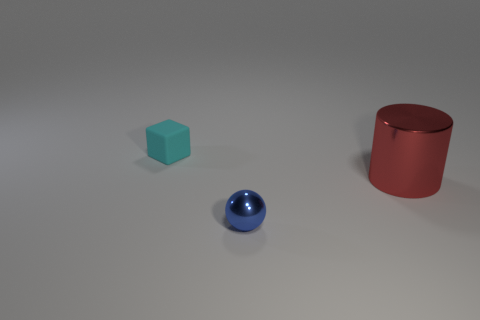Is there anything else that has the same size as the red cylinder?
Offer a terse response. No. Are there any other things that have the same shape as the cyan rubber thing?
Your answer should be very brief. No. There is a tiny matte thing on the left side of the red metallic thing; what is its shape?
Offer a very short reply. Cube. There is a object to the left of the blue object; is its size the same as the blue object?
Ensure brevity in your answer.  Yes. What is the size of the object that is behind the shiny ball and in front of the tiny cyan thing?
Your response must be concise. Large. What number of other small metal spheres are the same color as the sphere?
Offer a terse response. 0. Is the number of rubber things in front of the small shiny ball the same as the number of tiny cyan shiny things?
Ensure brevity in your answer.  Yes. The cylinder has what color?
Give a very brief answer. Red. There is a ball that is made of the same material as the red object; what is its size?
Provide a succinct answer. Small. The other object that is the same material as the large object is what color?
Your answer should be compact. Blue. 